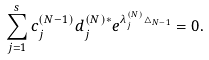Convert formula to latex. <formula><loc_0><loc_0><loc_500><loc_500>\sum ^ { s } _ { j = 1 } c _ { j } ^ { ( N - 1 ) } d _ { j } ^ { ( N ) * } e ^ { \lambda ^ { ( N ) } _ { j } \triangle _ { N - 1 } } = 0 .</formula> 